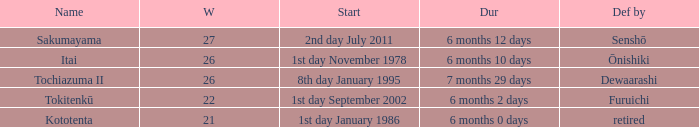How many wins, on average, were defeated by furuichi? 22.0. 